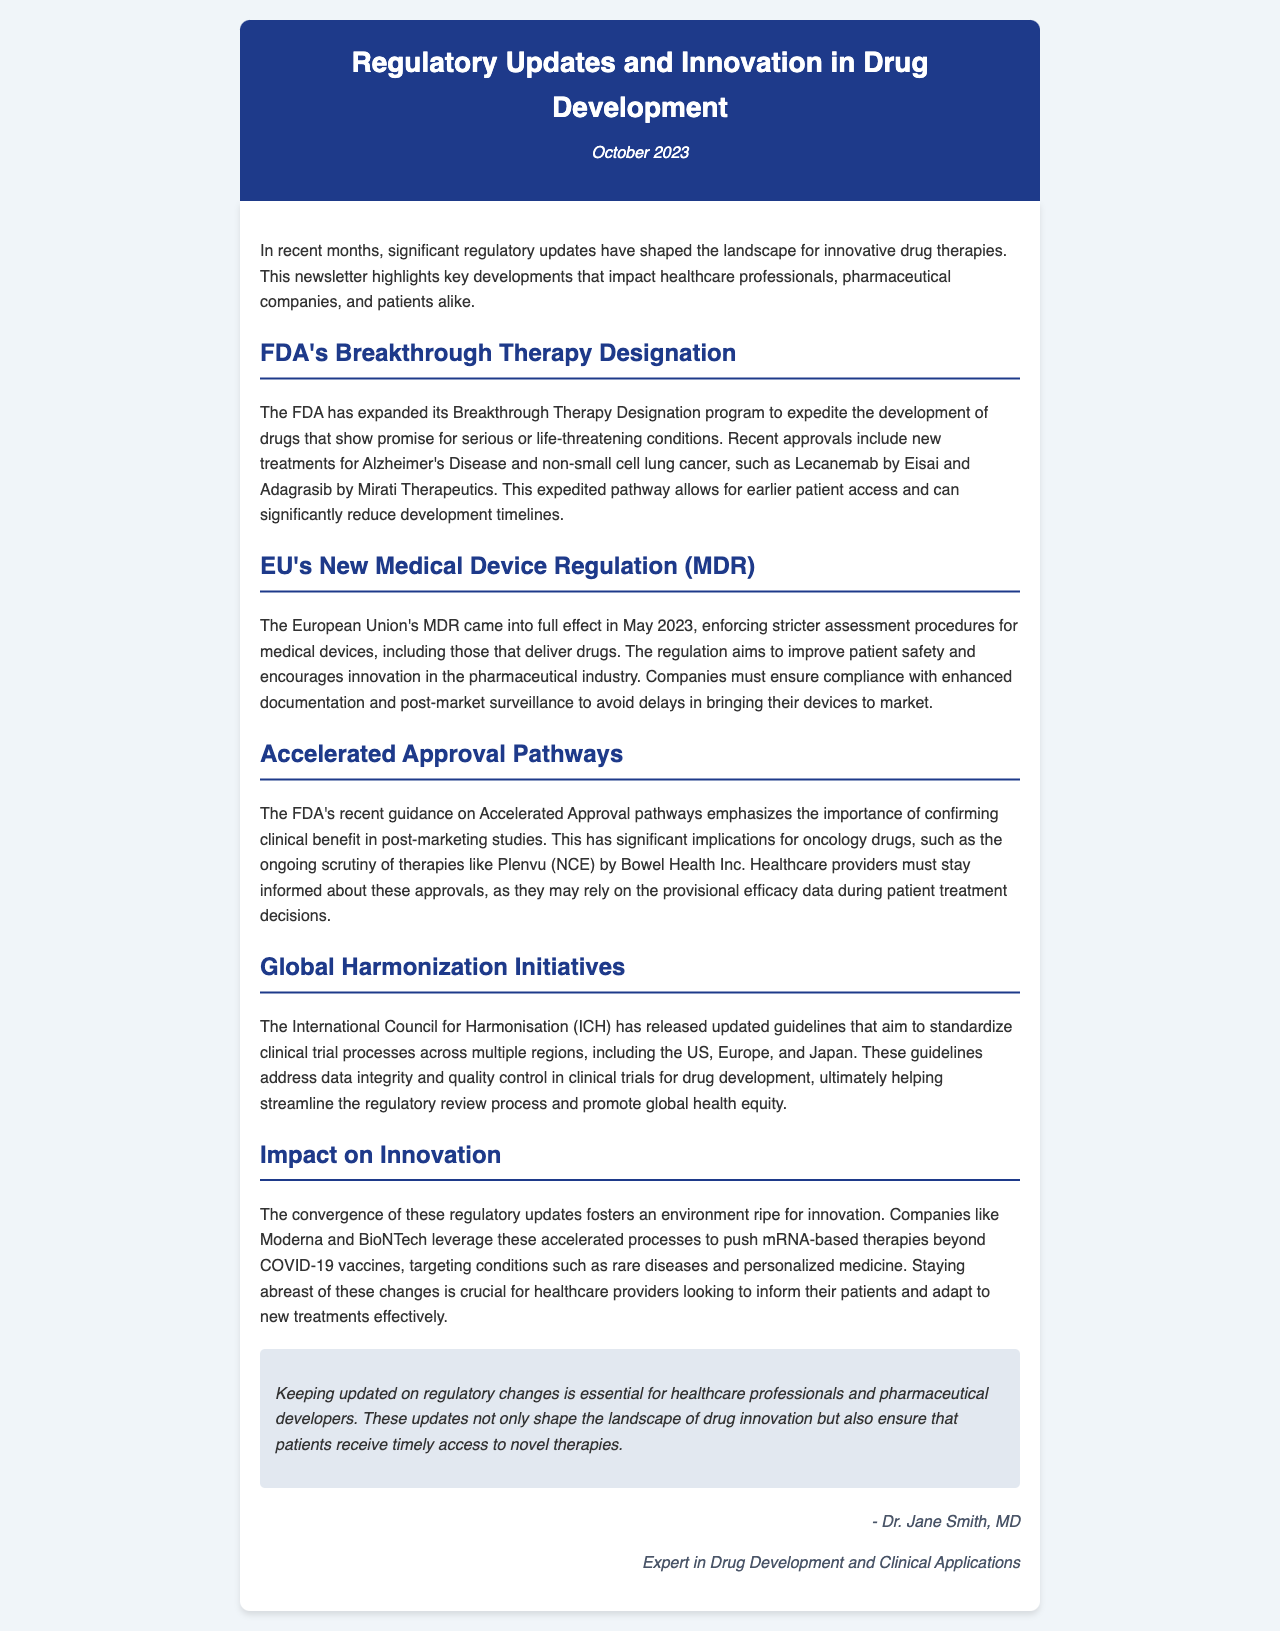what is the title of the newsletter? The title of the newsletter is mentioned in the header section, which states the main theme of the document.
Answer: Regulatory Updates and Innovation in Drug Development what date was the newsletter published? The date of publication is provided in the header section, indicating its relevance and timeliness.
Answer: October 2023 what recent approvals are included in the FDA's Breakthrough Therapy Designation? The newsletter lists specific drug therapies that received recent approvals, reflecting the practical applications of regulatory designations.
Answer: Lecanemab and Adagrasib when did the EU's New Medical Device Regulation come into effect? The document states the specific month and year when the new regulation was enforced, which is important for compliance purposes.
Answer: May 2023 what is the focus of the FDA's Accelerated Approval guidance? The newsletter discusses what healthcare providers should consider regarding drug approval processes, emphasizing the importance of clinical benefits.
Answer: Confirming clinical benefit which organization released guidelines for global harmonization of clinical trials? The document specifies the organization responsible for updating guidelines that standardize clinical trial processes, essential for international regulation.
Answer: International Council for Harmonisation how do Moderna and BioNTech plan to leverage recent regulatory updates? The newsletter illustrates how certain companies are using expedited processes to innovate beyond their initial products, which impacts drug development strategies.
Answer: mRNA-based therapies what is the overall conclusion regarding regulatory updates? The conclusion encapsulates the implications of keeping informed about regulatory developments and their impact on drug innovation and patient access.
Answer: Essential for timely access to novel therapies 